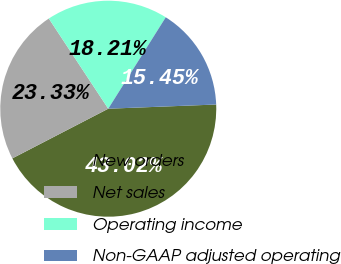Convert chart to OTSL. <chart><loc_0><loc_0><loc_500><loc_500><pie_chart><fcel>New orders<fcel>Net sales<fcel>Operating income<fcel>Non-GAAP adjusted operating<nl><fcel>43.02%<fcel>23.33%<fcel>18.21%<fcel>15.45%<nl></chart> 